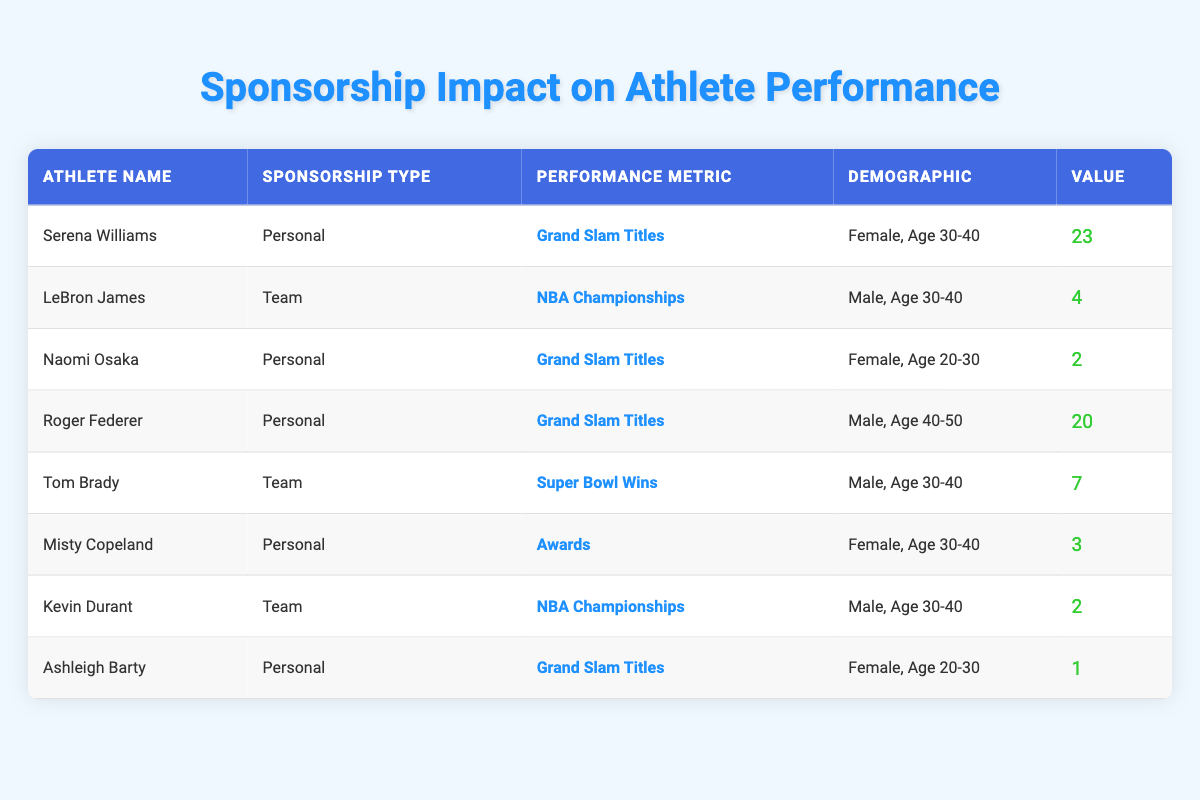What is the highest number of Grand Slam titles won by an athlete in the table? Looking at the "Performance Metric" column specifically for "Grand Slam Titles", Serena Williams has won 23 Grand Slam titles, which is the highest value among the listed athletes.
Answer: 23 How many athletes in the table have Personal sponsorships? By reviewing the "Sponsorship Type" column, we find that there are four athletes with Personal sponsorships: Serena Williams, Naomi Osaka, Roger Federer, and Ashleigh Barty.
Answer: 4 What is the total number of Super Bowl Wins listed in the table? There is only one athlete listed under the "Performance Metric" of "Super Bowl Wins," which is Tom Brady with 7 Wins. Therefore, the total is 7.
Answer: 7 Did any female athletes aged 20-30 achieve more Grand Slam titles than Ashleigh Barty? Ashleigh Barty has 1 Grand Slam title. The only other athlete in the demographic of female, age 20-30 is Naomi Osaka, who has 2 Grand Slam titles. Since 2 is greater than 1, the answer is yes.
Answer: Yes What is the average number of NBA Championships among the athletes listed with that performance metric? The athletes with NBA Championships are LeBron James (4) and Kevin Durant (2). The sum is 4 + 2 = 6. There are 2 athletes, so the average is 6 / 2 = 3.
Answer: 3 How does Misty Copeland's performance value compare to Roger Federer's? Misty Copeland has a performance value of 3 (for Awards), while Roger Federer has a value of 20 (for Grand Slam Titles). The difference shows Federer outperforming Copeland significantly; hence, Copeland's value is less than Rogers'.
Answer: Less Are there any male athletes with a performance metric of Awards in the table? By checking the "Performance Metric" column, we see that all male athletes listed are associated with either NBA Championships or Super Bowl Wins, and none have a metric of Awards. Therefore, the answer is no.
Answer: No Which demographic group has the highest average performance value? Focusing on the demographics, we calculate the averages: "Female, Age 30-40" has (23 + 3) / 2 = 13; "Male, Age 30-40" has (4 + 7 + 2) / 3 = 4.33; "Female, Age 20-30" has (2 + 1) / 2 = 1.5; "Male, Age 40-50" only has 20. Among these, the group "Female, Age 30-40" has the highest average performance value of 13.
Answer: Female, Age 30-40 What is the combined performance metric value for all athletes aged 30-40? For the demographic "Male, Age 30-40," the values are 4 (LeBron James) + 7 (Tom Brady) + 2 (Kevin Durant) = 13. For "Female, Age 30-40," we add 23 (Serena Williams) + 3 (Misty Copeland) = 26. Combining these gives a total of 13 + 26 = 39.
Answer: 39 